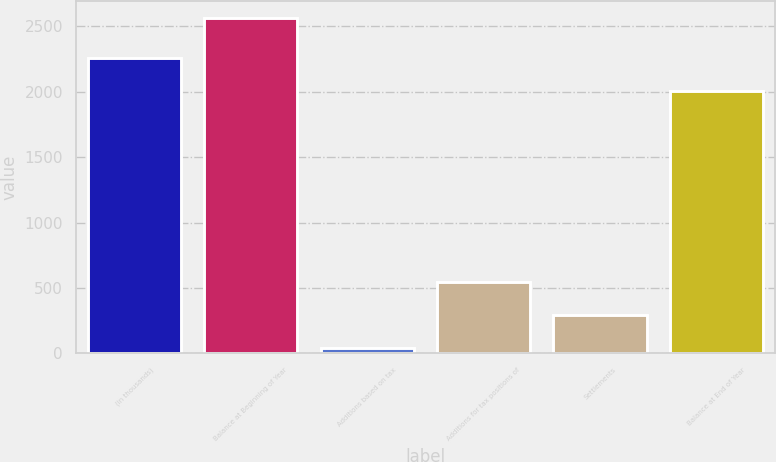<chart> <loc_0><loc_0><loc_500><loc_500><bar_chart><fcel>(in thousands)<fcel>Balance at Beginning of Year<fcel>Additions based on tax<fcel>Additions for tax positions of<fcel>Settlements<fcel>Balance at End of Year<nl><fcel>2261.3<fcel>2566<fcel>43<fcel>547.6<fcel>295.3<fcel>2009<nl></chart> 